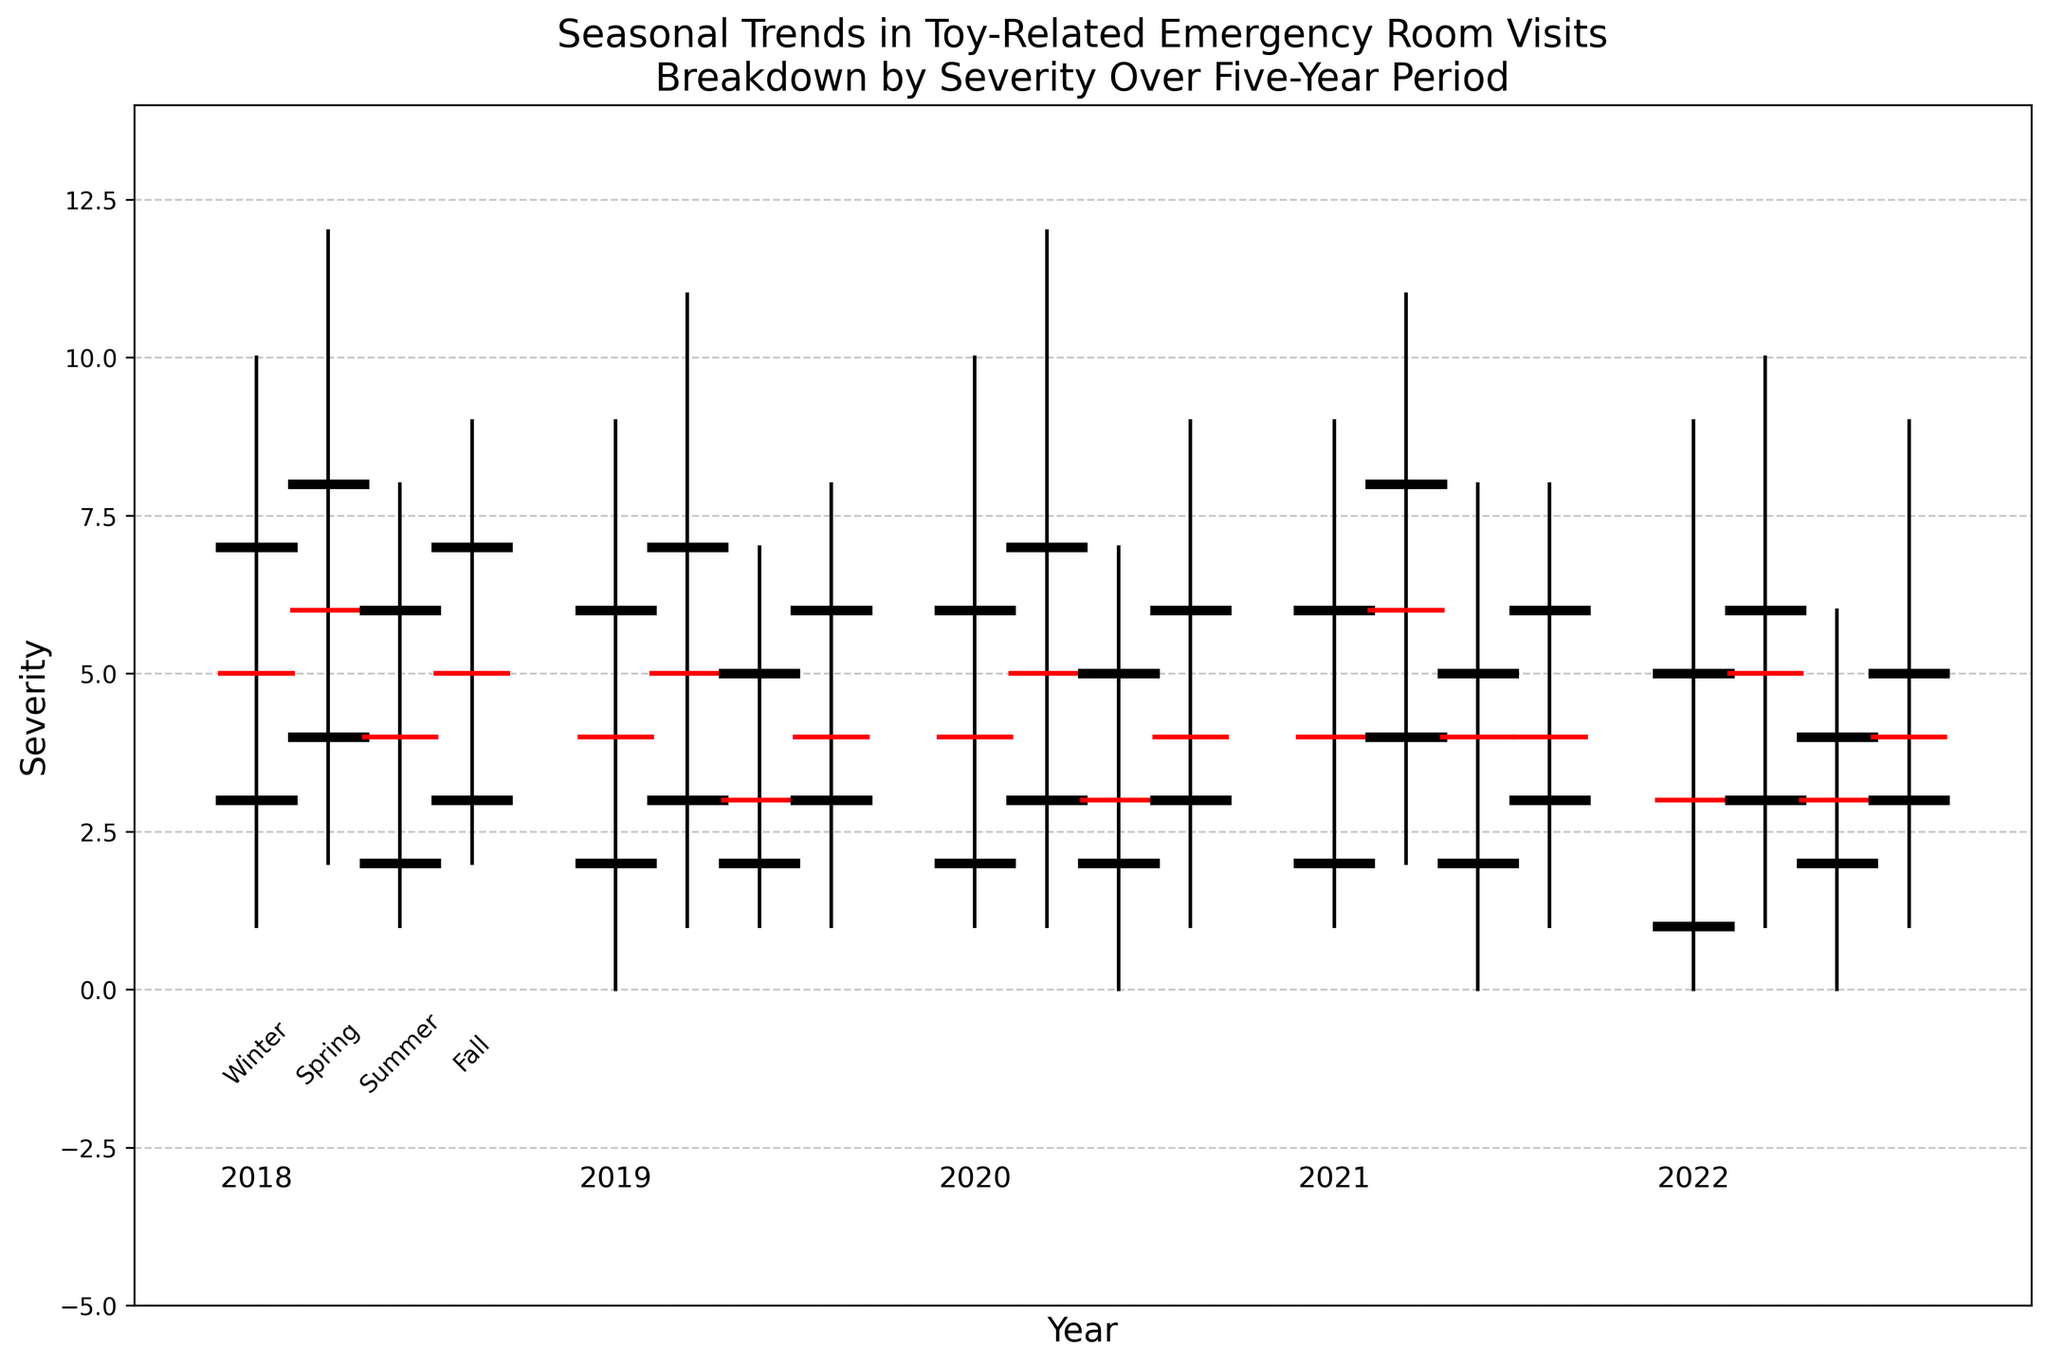what's the median severity of toy-related emergency visits in Spring 2018? Locate the year 2018 and the season Spring on the chart. Identify the middle horizontal bar, which represents the median severity. The value for Spring 2018 is 6.
Answer: 6 Which season had the highest maximum severity of toy-related ER visits in 2021? For 2021, compare the maximum vertical lines for each season. Identify the season with the longest line extending up. Spring has the highest maximum severity at 11.
Answer: Spring What's the difference in median severity between Summer and Fall in 2019? For 2019, locate the median horizontal lines for Summer (3) and Fall (4). Subtract the smaller median from the larger one: 4 - 3 = 1.
Answer: 1 Which year had the overall lowest minimum severity, and what was it? Compare the minimum points across all years. The year 2022 has the overall lowest minimum severity at 0.
Answer: 2022, 0 What's the range of severity for Winter in 2020, and how is it visually represented? The range is the difference between the maximum and minimum points. For Winter 2020, it ranges from a minimum of 1 to a maximum of 10. Visually, it's the distance between the endpoints of the vertical line. So, 10 - 1 = 9.
Answer: 9 How does the median severity of Summer in 2022 compare to that of Winter in 2019? Locate Summer 2022 and Winter 2019, then compare the median values. Summer 2022 has a median of 3, and Winter 2019 has a median of 4. Summer 2022 is less by 1.
Answer: Less by 1 In which season and year do we see the smallest interquartile range (IQR) of severity? IQR is the difference between the upper and lower quartile values. Check across all seasons and years. The smallest IQR is in Summer 2022, with values of 4 - 2 = 2.
Answer: Summer 2022 During which years was the maximum severity for Fall consistently 9 or less? Examine the Fall data for each year; check maximum severity values. For 2018, 2019, 2020, and 2022, the maximum severity was 9 or less.
Answer: 2018, 2019, 2020, 2022 